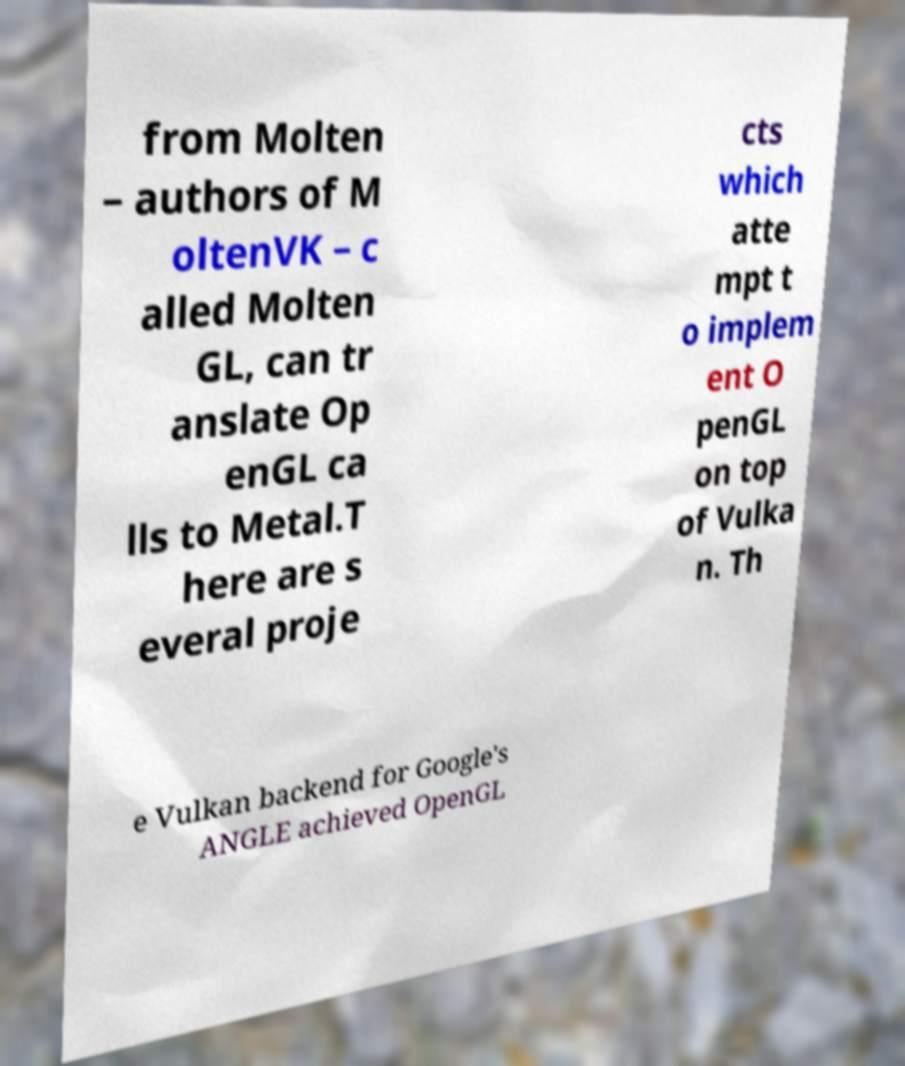Please read and relay the text visible in this image. What does it say? from Molten – authors of M oltenVK – c alled Molten GL, can tr anslate Op enGL ca lls to Metal.T here are s everal proje cts which atte mpt t o implem ent O penGL on top of Vulka n. Th e Vulkan backend for Google's ANGLE achieved OpenGL 